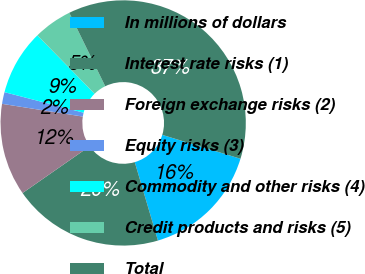Convert chart. <chart><loc_0><loc_0><loc_500><loc_500><pie_chart><fcel>In millions of dollars<fcel>Interest rate risks (1)<fcel>Foreign exchange risks (2)<fcel>Equity risks (3)<fcel>Commodity and other risks (4)<fcel>Credit products and risks (5)<fcel>Total<nl><fcel>15.71%<fcel>19.89%<fcel>12.17%<fcel>1.55%<fcel>8.63%<fcel>5.09%<fcel>36.95%<nl></chart> 